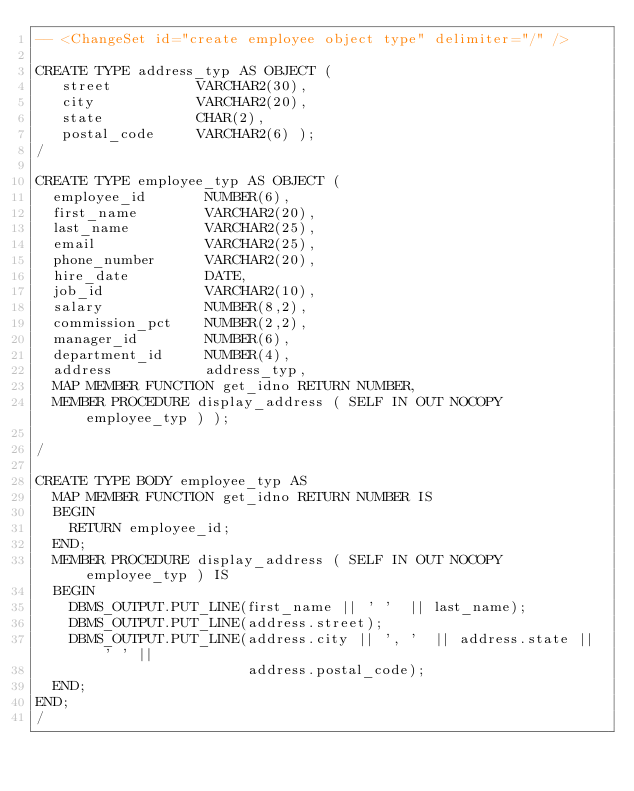Convert code to text. <code><loc_0><loc_0><loc_500><loc_500><_SQL_>-- <ChangeSet id="create employee object type" delimiter="/" />

CREATE TYPE address_typ AS OBJECT (
   street          VARCHAR2(30),
   city            VARCHAR2(20),
   state           CHAR(2),
   postal_code     VARCHAR2(6) );
/

CREATE TYPE employee_typ AS OBJECT (
  employee_id       NUMBER(6),
  first_name        VARCHAR2(20),
  last_name         VARCHAR2(25),
  email             VARCHAR2(25),
  phone_number      VARCHAR2(20),
  hire_date         DATE,
  job_id            VARCHAR2(10),
  salary            NUMBER(8,2),
  commission_pct    NUMBER(2,2),
  manager_id        NUMBER(6),
  department_id     NUMBER(4),
  address           address_typ,
  MAP MEMBER FUNCTION get_idno RETURN NUMBER,
  MEMBER PROCEDURE display_address ( SELF IN OUT NOCOPY employee_typ ) );

/

CREATE TYPE BODY employee_typ AS
  MAP MEMBER FUNCTION get_idno RETURN NUMBER IS
  BEGIN
    RETURN employee_id;
  END;
  MEMBER PROCEDURE display_address ( SELF IN OUT NOCOPY employee_typ ) IS
  BEGIN
    DBMS_OUTPUT.PUT_LINE(first_name || ' '  || last_name);
    DBMS_OUTPUT.PUT_LINE(address.street);
    DBMS_OUTPUT.PUT_LINE(address.city || ', '  || address.state || ' ' ||
                         address.postal_code);
  END;
END;
/
</code> 